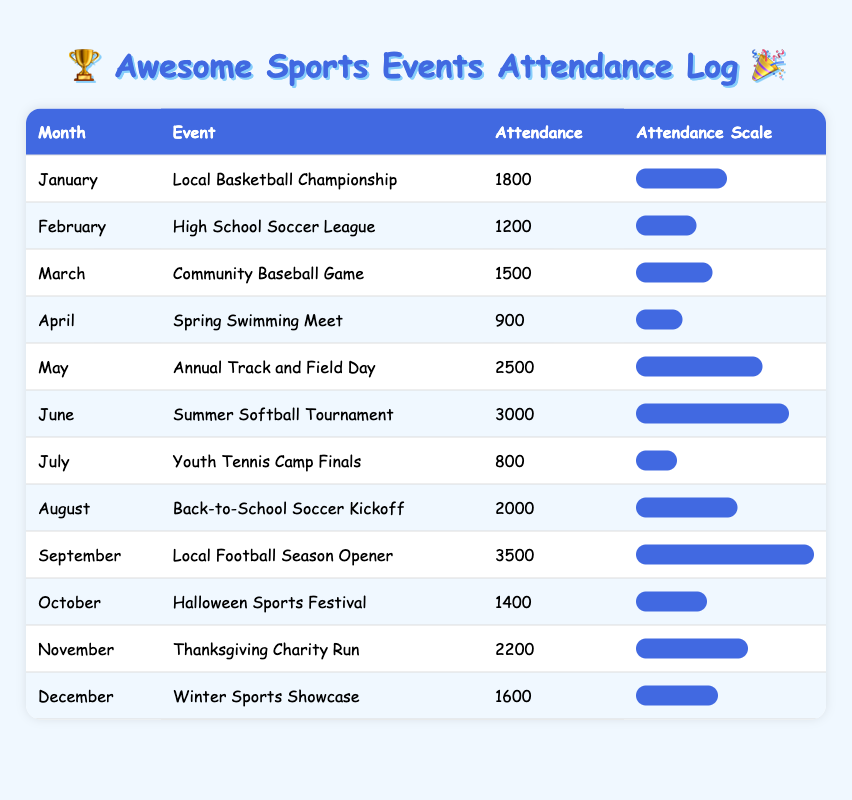What is the attendance at the Local Basketball Championship in January? The table shows that the attendance for the Local Basketball Championship in January is 1800. You can find this by looking at the row for January, which lists this event in the second column.
Answer: 1800 Which event had the highest attendance and what was it? By reviewing the attendance values in the table, September's Local Football Season Opener had the highest attendance of 3500, which is the maximum number listed in the attendance column.
Answer: Local Football Season Opener, 3500 What is the total attendance for the events in the summer months (June, July, August)? First, we identify the events in the summer months: June (3000), July (800), and August (2000). Next, we sum these attendances: 3000 + 800 + 2000 = 5800.
Answer: 5800 Did the Thanksgiving Charity Run have a higher attendance than the Winter Sports Showcase? Looking at the table, the Thanksgiving Charity Run had an attendance of 2200, while the Winter Sports Showcase had an attendance of 1600. Since 2200 > 1600, the answer is yes.
Answer: Yes What is the average attendance for the events that occurred in the first half of the year (January to June)? We first note the attendances for the first six months: January (1800), February (1200), March (1500), April (900), May (2500), June (3000). Then, we calculate the total attendance: 1800 + 1200 + 1500 + 900 + 2500 + 3000 = 10900. Finally, we divide by the number of months (6) to find the average: 10900 / 6 = 1816.67.
Answer: 1816.67 In what month did the Spring Swimming Meet take place, and what was its attendance? From the table, the Spring Swimming Meet took place in April, with an attendance of 900. This information can be found directly in the row corresponding to April.
Answer: April, 900 